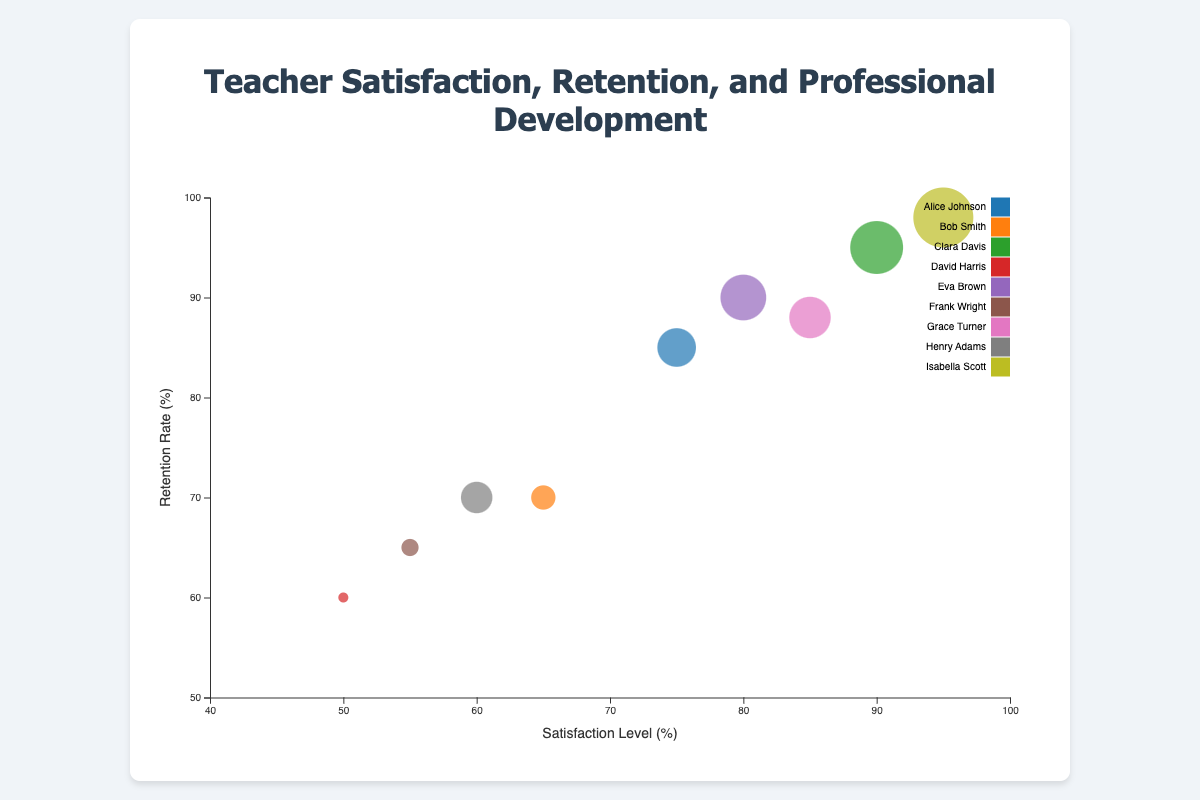What is the title of the chart? The title of the chart is usually written at the top, and in this chart, it reads "Teacher Satisfaction, Retention, and Professional Development".
Answer: Teacher Satisfaction, Retention, and Professional Development Which teacher has the highest satisfaction level? Look at the x-axis (Satisfaction Level) and find the bubble with the highest x-coordinate. This is "Isabella Scott" with a satisfaction level of 95%.
Answer: Isabella Scott How many teachers have a retention rate above 90%? Look at the y-axis and count the number of bubbles with a y-coordinate above the 90% mark. This includes Clara Davis, Eva Brown, and Isabella Scott.
Answer: 3 What is the average retention rate of teachers with at least 40 professional development hours? Identify teachers with at least 40 professional development hours: Alice Johnson, Clara Davis, Eva Brown, Grace Turner, and Isabella Scott. Their retention rates are 85%, 95%, 90%, 88%, and 98%, respectively. The average is (85 + 95 + 90 + 88 + 98) / 5 = 91.2%.
Answer: 91.2% Who has the least professional development hours, and what are their satisfaction and retention rates? Find the smallest bubble, which represents the least professional development hours. It is David Harris with 20 hours. His satisfaction level is 50% and retention rate is 60%.
Answer: David Harris: 50% satisfaction, 60% retention What is the professional development hours range represented in the chart? Look at the size of the smallest and largest bubbles to identify the range. The smallest bubble has 20 hours (David Harris) and the largest has 55 hours (Isabella Scott).
Answer: 20 to 55 hours Is there a relationship between satisfaction levels and retention rates for teachers? Examine the overall trend of the bubbles. As satisfaction levels increase on the x-axis, retention rates on the y-axis also seem to increase, indicating a positive correlation.
Answer: Positive correlation Which teacher has one of the largest bubbles and where is it located in terms of satisfaction and retention? Identify the largest bubbles by their sizes. Isabella Scott has one of the largest bubbles, located at 95% satisfaction and 98% retention.
Answer: Isabella Scott: 95% satisfaction, 98% retention Compare the satisfaction levels and professional development hours of Bob Smith and Frank Wright. Bob Smith has a satisfaction level of 65% and 30 hours of professional development. Frank Wright has a satisfaction level of 55% and 25 hours of professional development. Bob Smith has higher satisfaction and more professional development hours.
Answer: Bob Smith has higher satisfaction and more professional development hours Which teacher has a higher satisfaction level: Alice Johnson or Grace Turner? Compare the x-coordinates of the bubbles for Alice Johnson and Grace Turner. Alice Johnson has a satisfaction level of 75%, while Grace Turner has 85%.
Answer: Grace Turner 